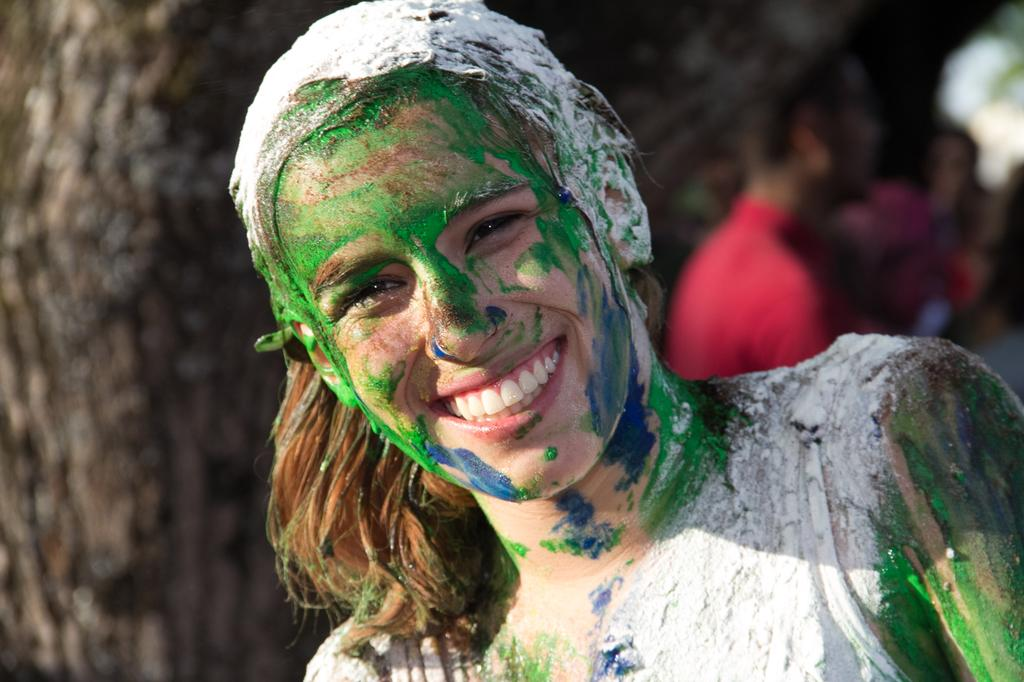Who is the main subject in the image? There is a woman in the image. What is unique about the woman's appearance? The woman has painted colors on her face. What expression does the woman have? The woman is smiling. What is the woman doing in the image? The woman is giving a pose for the picture. Can you describe the background of the image? There are more people in the background of the image. What type of pies can be seen in the woman's hands in the image? There are no pies present in the image; the woman has painted colors on her face and is posing for the picture. What kind of flower is the woman holding in the image? There is no flower present in the image; the woman has painted colors on her face and is posing for the picture. 